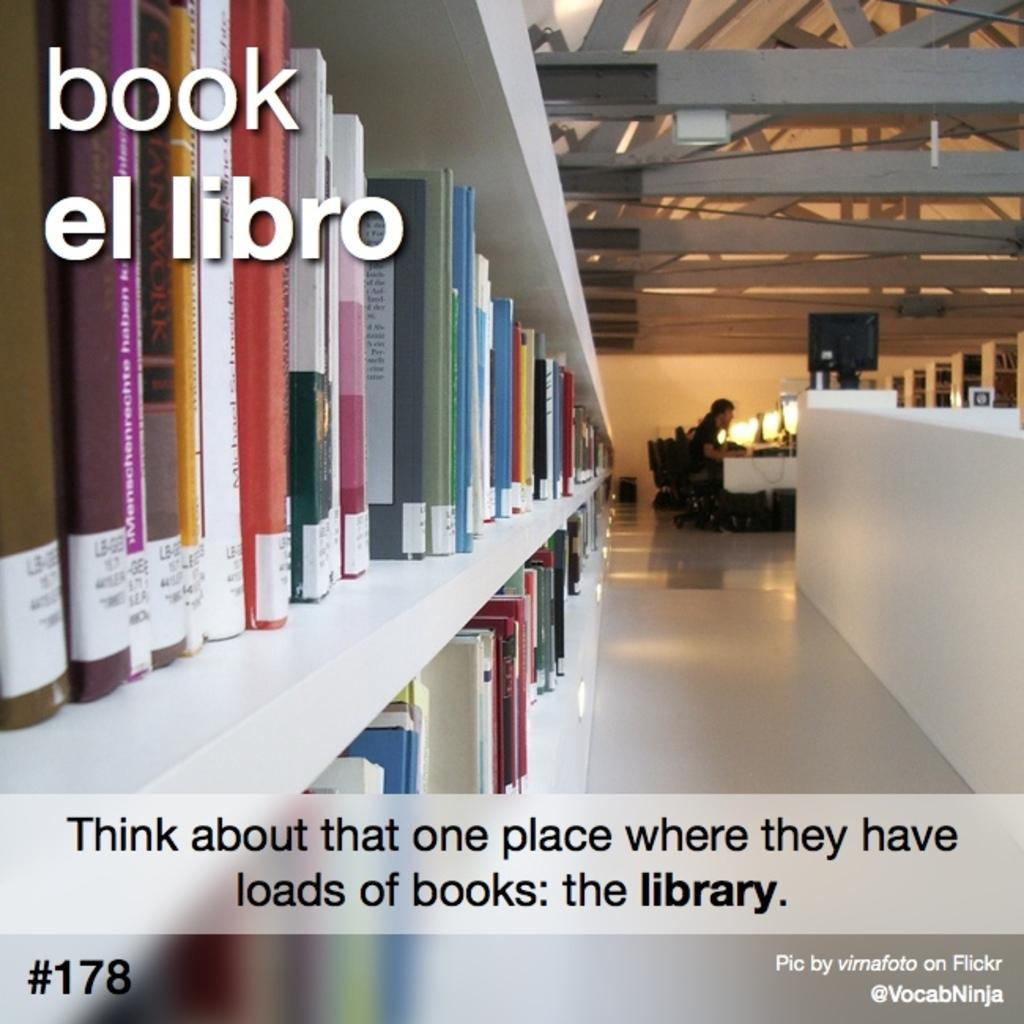<image>
Relay a brief, clear account of the picture shown. A poster conveying the message that more people should go to the library show a woman, inside a library, working at a desk, in the distance. 